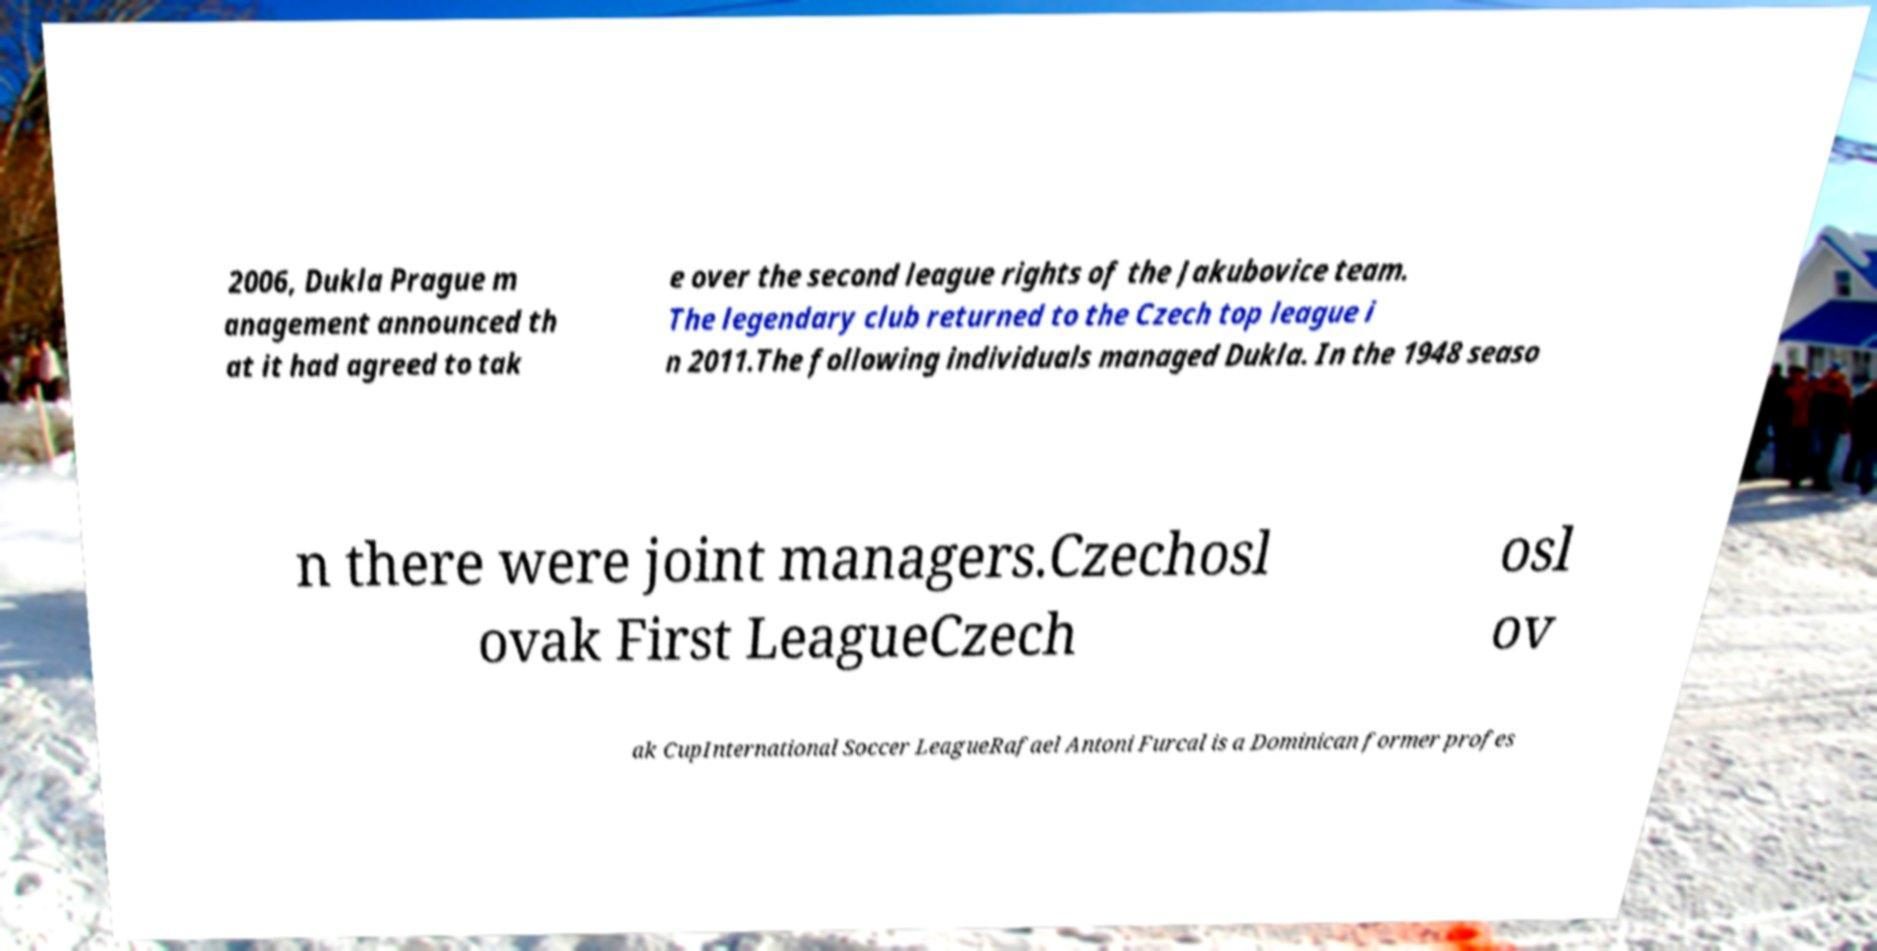I need the written content from this picture converted into text. Can you do that? 2006, Dukla Prague m anagement announced th at it had agreed to tak e over the second league rights of the Jakubovice team. The legendary club returned to the Czech top league i n 2011.The following individuals managed Dukla. In the 1948 seaso n there were joint managers.Czechosl ovak First LeagueCzech osl ov ak CupInternational Soccer LeagueRafael Antoni Furcal is a Dominican former profes 